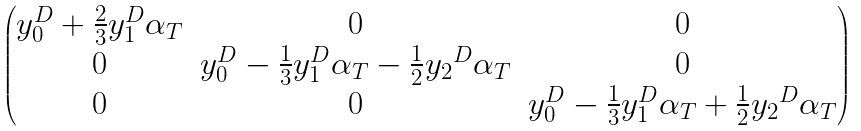Convert formula to latex. <formula><loc_0><loc_0><loc_500><loc_500>\begin{pmatrix} y _ { 0 } ^ { D } + \frac { 2 } { 3 } y _ { 1 } ^ { D } \alpha _ { T } & 0 & 0 \\ 0 & y _ { 0 } ^ { D } - \frac { 1 } { 3 } y _ { 1 } ^ { D } \alpha _ { T } - \frac { 1 } { 2 } { y _ { 2 } } ^ { D } \alpha _ { T } & 0 \\ 0 & 0 & y _ { 0 } ^ { D } - \frac { 1 } { 3 } y _ { 1 } ^ { D } \alpha _ { T } + \frac { 1 } { 2 } { y _ { 2 } } ^ { D } \alpha _ { T } \end{pmatrix}</formula> 